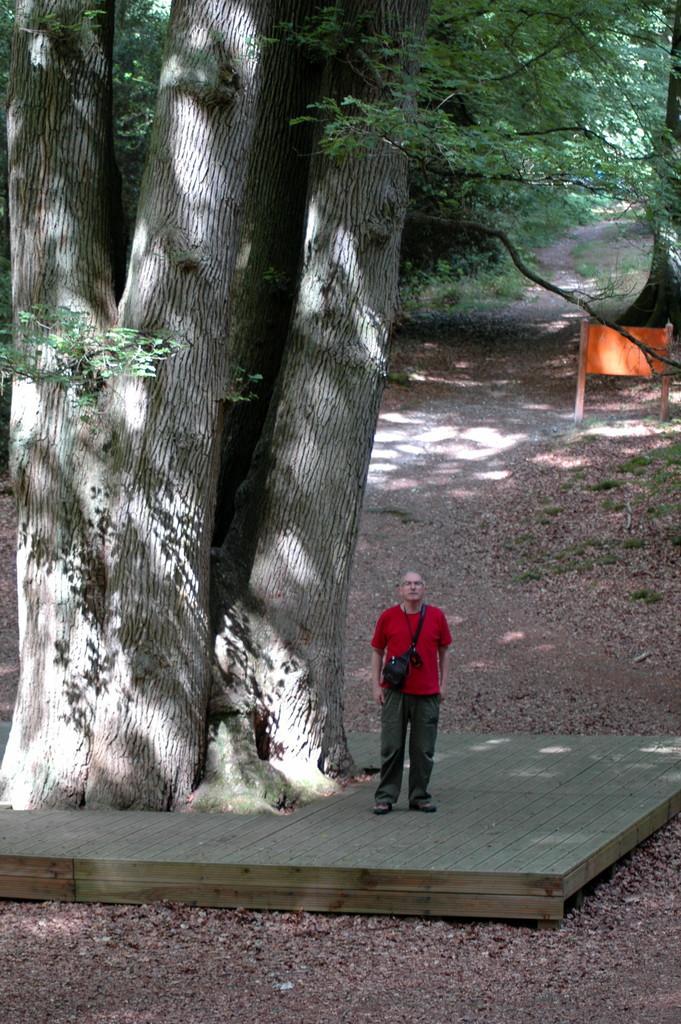Please provide a concise description of this image. In this image, we can see a person standing on a surface. There are some trees. We can see a banner. We can see the ground. We can see some grass, plants. 